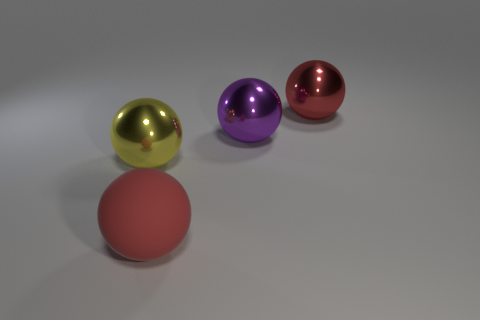Add 4 metallic things. How many objects exist? 8 Add 4 gray objects. How many gray objects exist? 4 Subtract 0 blue cylinders. How many objects are left? 4 Subtract all large matte things. Subtract all green metal spheres. How many objects are left? 3 Add 3 big balls. How many big balls are left? 7 